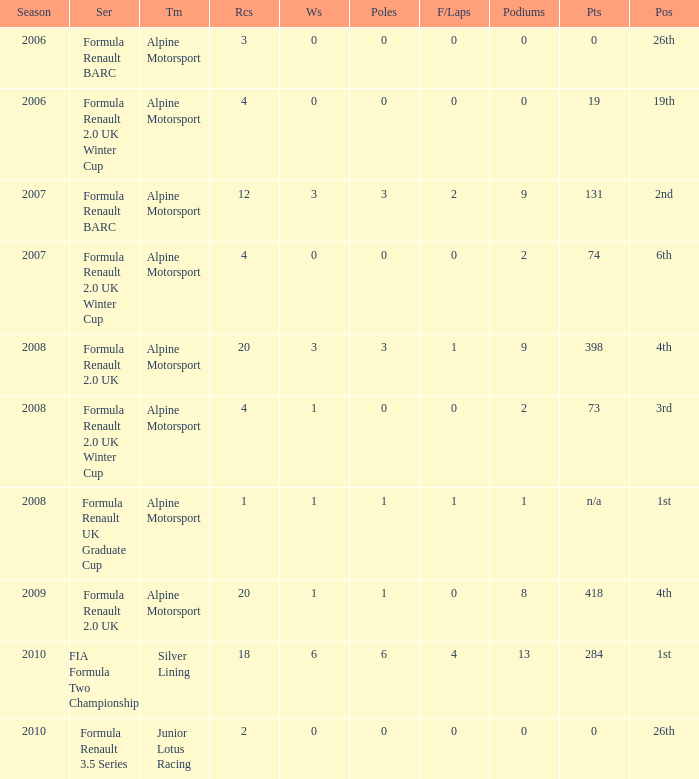How much were the f/laps if poles is higher than 1.0 during 2008? 1.0. 